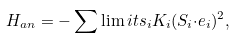<formula> <loc_0><loc_0><loc_500><loc_500>H _ { a n } = - \sum \lim i t s _ { i } K _ { i } ( { S } _ { i } { \cdot e } _ { i } ) ^ { 2 } ,</formula> 